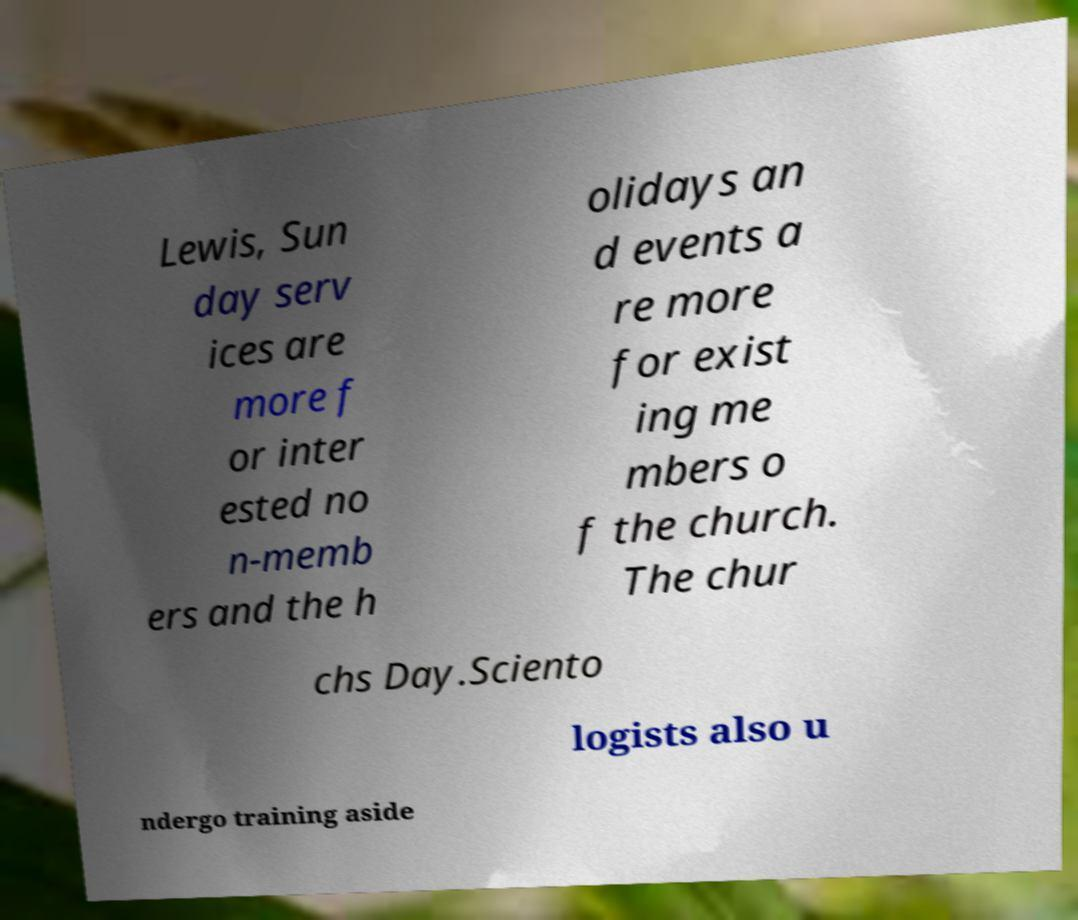Please read and relay the text visible in this image. What does it say? Lewis, Sun day serv ices are more f or inter ested no n-memb ers and the h olidays an d events a re more for exist ing me mbers o f the church. The chur chs Day.Sciento logists also u ndergo training aside 